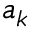<formula> <loc_0><loc_0><loc_500><loc_500>{ a } _ { k }</formula> 